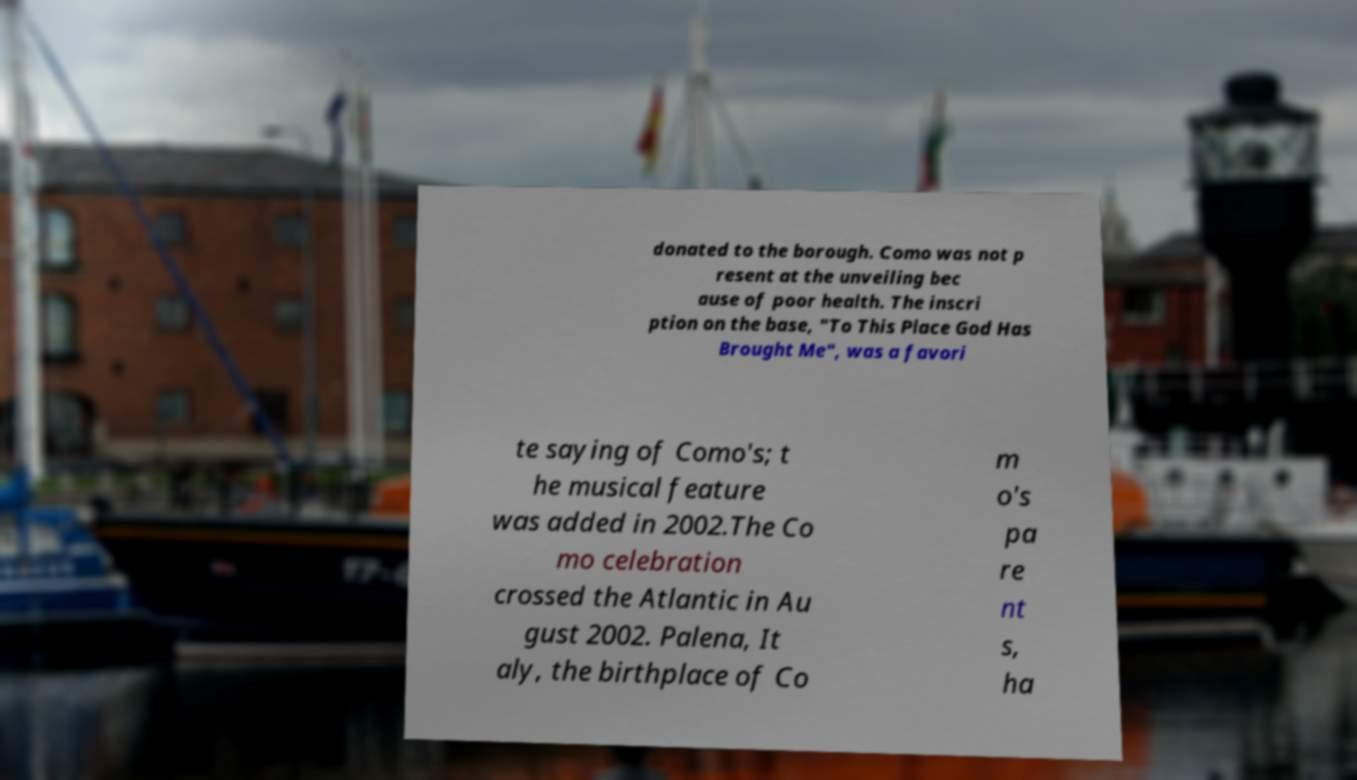Please identify and transcribe the text found in this image. donated to the borough. Como was not p resent at the unveiling bec ause of poor health. The inscri ption on the base, "To This Place God Has Brought Me", was a favori te saying of Como's; t he musical feature was added in 2002.The Co mo celebration crossed the Atlantic in Au gust 2002. Palena, It aly, the birthplace of Co m o's pa re nt s, ha 